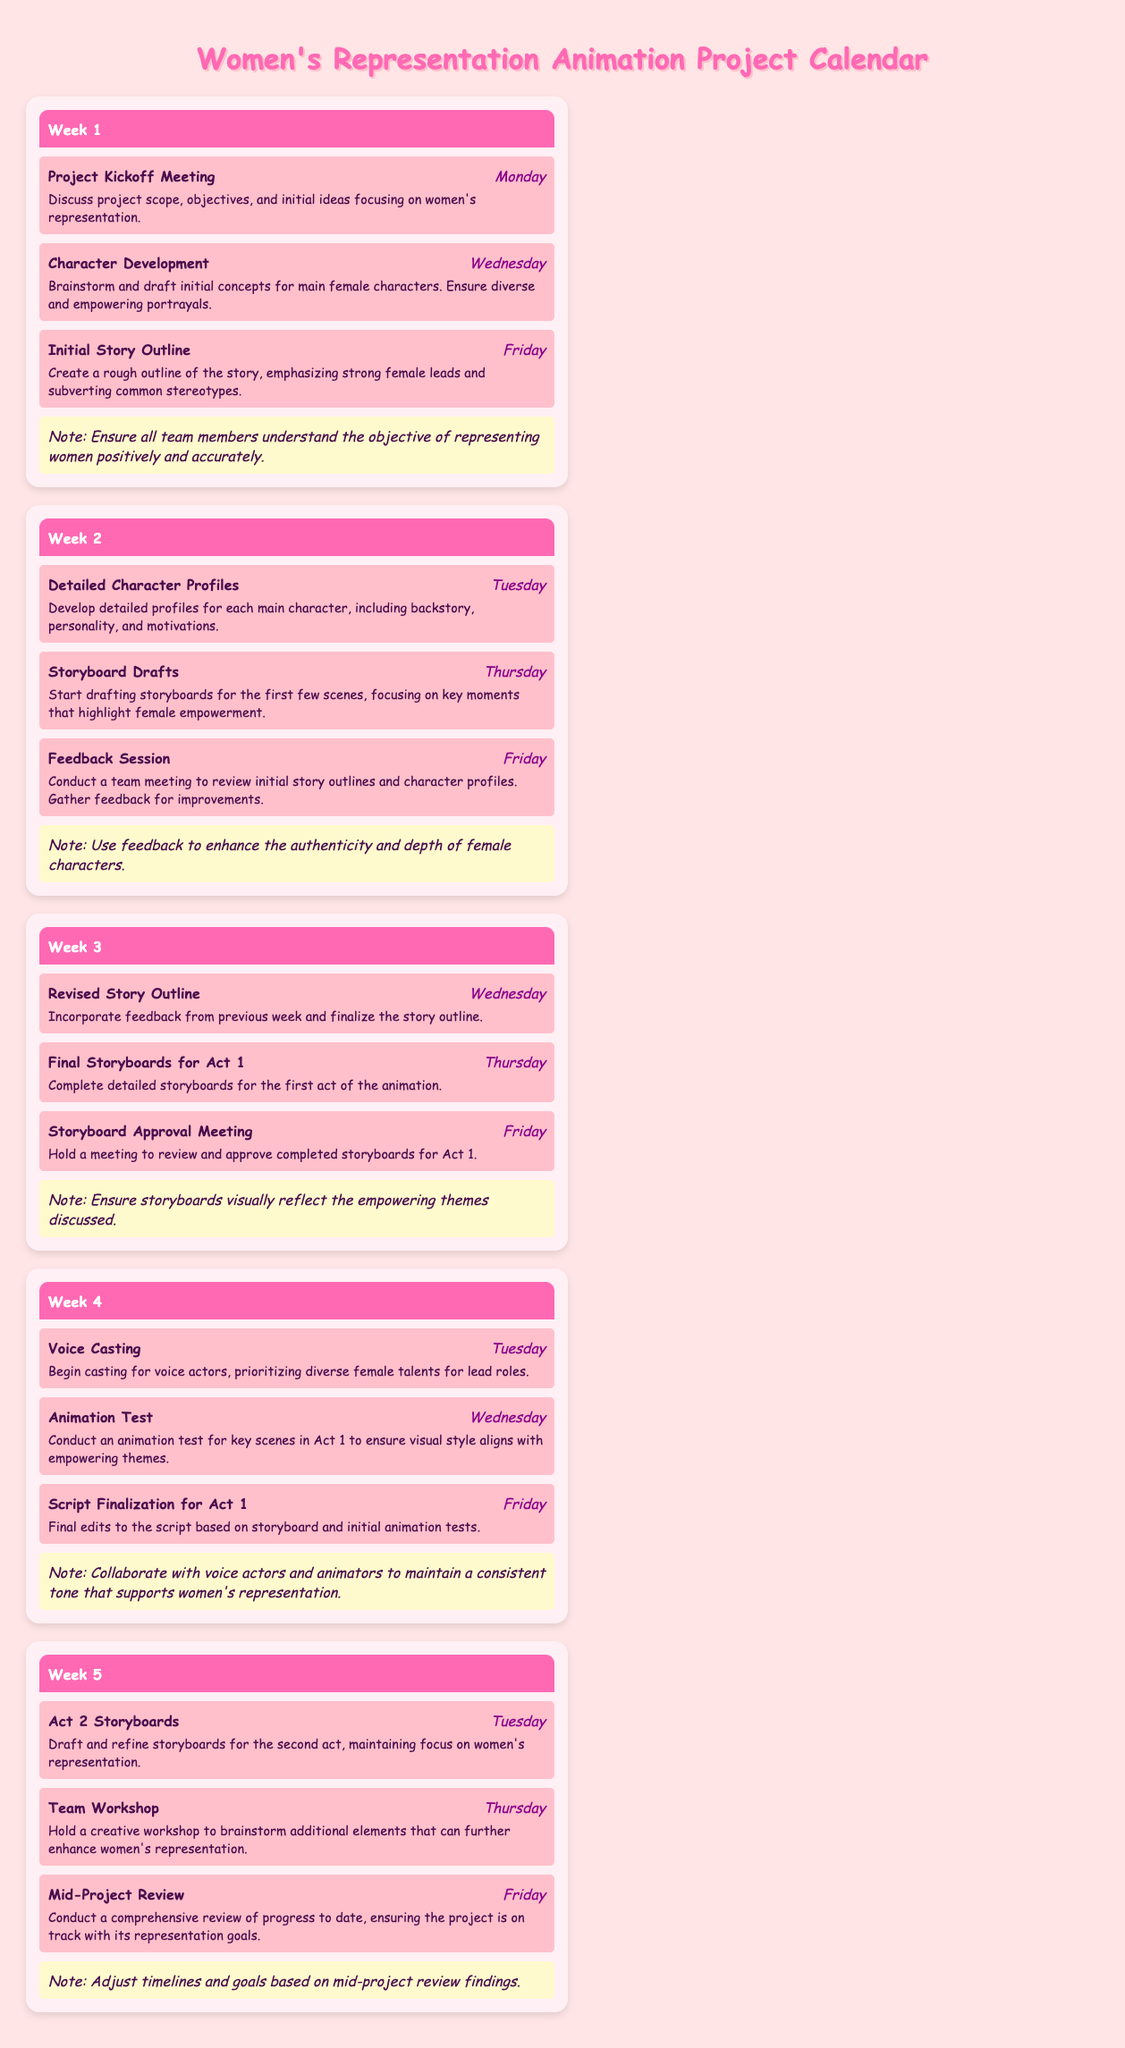What is the focus of the first project meeting? The project kickoff meeting is centered around discussing the project scope, objectives, and initial ideas focusing on women's representation.
Answer: Women's representation When is the storyboard approval meeting scheduled? The storyboard approval meeting is listed under Week 3 with a deadline on Friday.
Answer: Friday How many weeks are outlined in the calendar? The document outlines a total of five weeks of development milestones.
Answer: Five weeks What is the task due on Tuesday of Week 4? The task due on Tuesday of Week 4 is related to voice casting, specifically beginning casting for voice actors.
Answer: Voice Casting What does the team workshop in Week 5 aim to achieve? The team workshop in Week 5 is intended to brainstorm additional elements that can further enhance women's representation.
Answer: Enhance women's representation Which week includes the detailed character profiles task? The detailed character profiles task is scheduled for Week 2.
Answer: Week 2 What is the main goal of the mid-project review in Week 5? The main goal of the mid-project review is to conduct a comprehensive review of progress to ensure alignment with representation goals.
Answer: Ensure alignment with representation goals What key elements are emphasized in the initial story outline task? The key elements emphasized in the initial story outline are strong female leads and subverting common stereotypes.
Answer: Strong female leads When are the detailed storyboards for Act 1 due? The detailed storyboards for Act 1 are due on Thursday of Week 3.
Answer: Thursday 